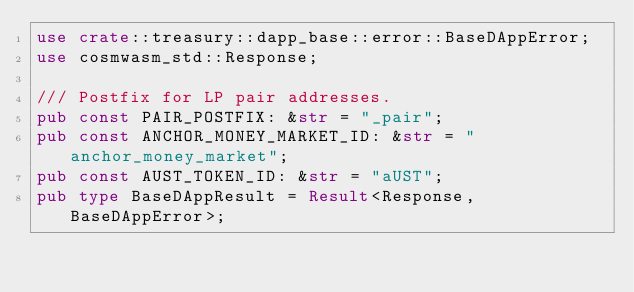Convert code to text. <code><loc_0><loc_0><loc_500><loc_500><_Rust_>use crate::treasury::dapp_base::error::BaseDAppError;
use cosmwasm_std::Response;

/// Postfix for LP pair addresses.
pub const PAIR_POSTFIX: &str = "_pair";
pub const ANCHOR_MONEY_MARKET_ID: &str = "anchor_money_market";
pub const AUST_TOKEN_ID: &str = "aUST";
pub type BaseDAppResult = Result<Response, BaseDAppError>;
</code> 